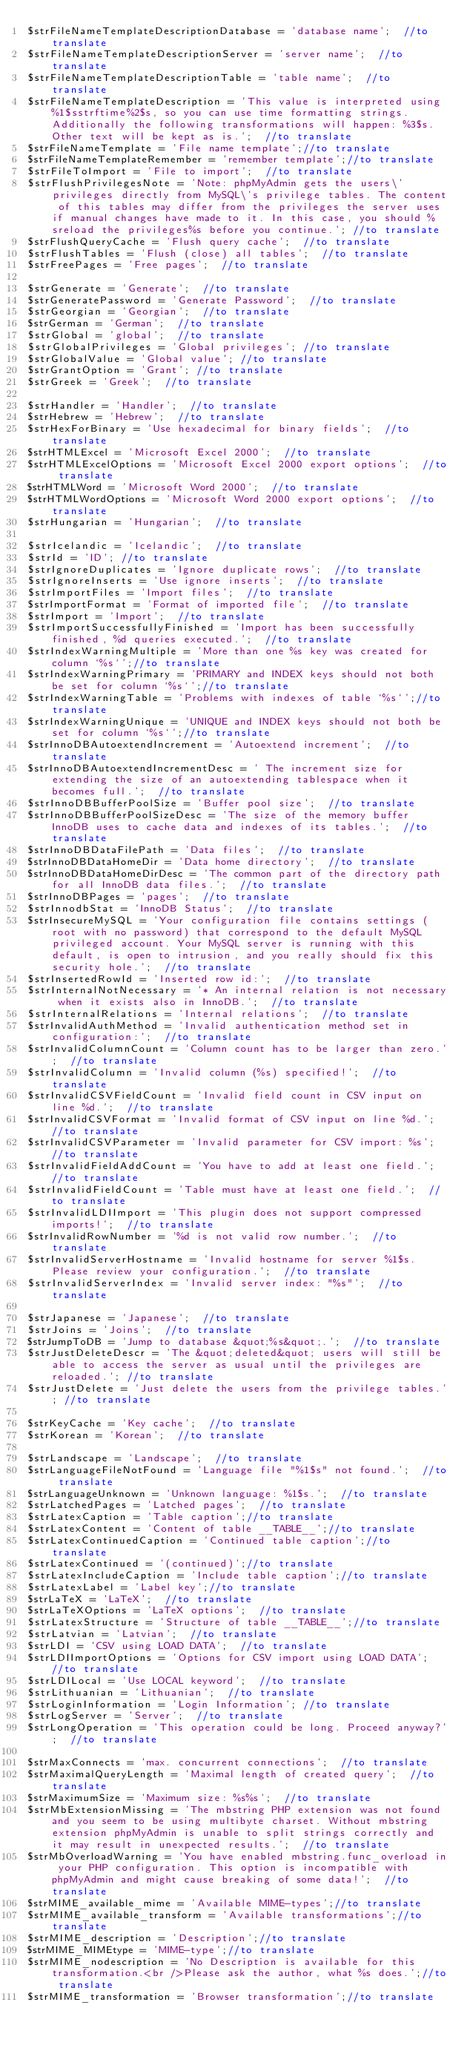Convert code to text. <code><loc_0><loc_0><loc_500><loc_500><_PHP_>$strFileNameTemplateDescriptionDatabase = 'database name';  //to translate
$strFileNameTemplateDescriptionServer = 'server name';  //to translate
$strFileNameTemplateDescriptionTable = 'table name';  //to translate
$strFileNameTemplateDescription = 'This value is interpreted using %1$sstrftime%2$s, so you can use time formatting strings. Additionally the following transformations will happen: %3$s. Other text will be kept as is.';  //to translate
$strFileNameTemplate = 'File name template';//to translate
$strFileNameTemplateRemember = 'remember template';//to translate
$strFileToImport = 'File to import';  //to translate
$strFlushPrivilegesNote = 'Note: phpMyAdmin gets the users\' privileges directly from MySQL\'s privilege tables. The content of this tables may differ from the privileges the server uses if manual changes have made to it. In this case, you should %sreload the privileges%s before you continue.'; //to translate
$strFlushQueryCache = 'Flush query cache';  //to translate
$strFlushTables = 'Flush (close) all tables';  //to translate
$strFreePages = 'Free pages';  //to translate

$strGenerate = 'Generate';  //to translate
$strGeneratePassword = 'Generate Password';  //to translate
$strGeorgian = 'Georgian';  //to translate
$strGerman = 'German';  //to translate
$strGlobal = 'global';  //to translate
$strGlobalPrivileges = 'Global privileges'; //to translate
$strGlobalValue = 'Global value'; //to translate
$strGrantOption = 'Grant'; //to translate
$strGreek = 'Greek';  //to translate

$strHandler = 'Handler';  //to translate
$strHebrew = 'Hebrew';  //to translate
$strHexForBinary = 'Use hexadecimal for binary fields';  //to translate
$strHTMLExcel = 'Microsoft Excel 2000';  //to translate
$strHTMLExcelOptions = 'Microsoft Excel 2000 export options';  //to translate
$strHTMLWord = 'Microsoft Word 2000';  //to translate
$strHTMLWordOptions = 'Microsoft Word 2000 export options';  //to translate
$strHungarian = 'Hungarian';  //to translate

$strIcelandic = 'Icelandic';  //to translate
$strId = 'ID'; //to translate
$strIgnoreDuplicates = 'Ignore duplicate rows';  //to translate
$strIgnoreInserts = 'Use ignore inserts';  //to translate
$strImportFiles = 'Import files';  //to translate
$strImportFormat = 'Format of imported file';  //to translate
$strImport = 'Import';  //to translate
$strImportSuccessfullyFinished = 'Import has been successfully finished, %d queries executed.';  //to translate
$strIndexWarningMultiple = 'More than one %s key was created for column `%s`';//to translate
$strIndexWarningPrimary = 'PRIMARY and INDEX keys should not both be set for column `%s`';//to translate
$strIndexWarningTable = 'Problems with indexes of table `%s`';//to translate
$strIndexWarningUnique = 'UNIQUE and INDEX keys should not both be set for column `%s`';//to translate
$strInnoDBAutoextendIncrement = 'Autoextend increment';  //to translate
$strInnoDBAutoextendIncrementDesc = ' The increment size for extending the size of an autoextending tablespace when it becomes full.';  //to translate
$strInnoDBBufferPoolSize = 'Buffer pool size';  //to translate
$strInnoDBBufferPoolSizeDesc = 'The size of the memory buffer InnoDB uses to cache data and indexes of its tables.';  //to translate
$strInnoDBDataFilePath = 'Data files';  //to translate
$strInnoDBDataHomeDir = 'Data home directory';  //to translate
$strInnoDBDataHomeDirDesc = 'The common part of the directory path for all InnoDB data files.';  //to translate
$strInnoDBPages = 'pages';  //to translate
$strInnodbStat = 'InnoDB Status';  //to translate
$strInsecureMySQL = 'Your configuration file contains settings (root with no password) that correspond to the default MySQL privileged account. Your MySQL server is running with this default, is open to intrusion, and you really should fix this security hole.';  //to translate
$strInsertedRowId = 'Inserted row id:';  //to translate
$strInternalNotNecessary = '* An internal relation is not necessary when it exists also in InnoDB.';  //to translate
$strInternalRelations = 'Internal relations';  //to translate
$strInvalidAuthMethod = 'Invalid authentication method set in configuration:';  //to translate
$strInvalidColumnCount = 'Column count has to be larger than zero.';  //to translate
$strInvalidColumn = 'Invalid column (%s) specified!';  //to translate
$strInvalidCSVFieldCount = 'Invalid field count in CSV input on line %d.';  //to translate
$strInvalidCSVFormat = 'Invalid format of CSV input on line %d.';  //to translate
$strInvalidCSVParameter = 'Invalid parameter for CSV import: %s';  //to translate
$strInvalidFieldAddCount = 'You have to add at least one field.';  //to translate
$strInvalidFieldCount = 'Table must have at least one field.';  //to translate
$strInvalidLDIImport = 'This plugin does not support compressed imports!';  //to translate
$strInvalidRowNumber = '%d is not valid row number.';  //to translate
$strInvalidServerHostname = 'Invalid hostname for server %1$s. Please review your configuration.';  //to translate
$strInvalidServerIndex = 'Invalid server index: "%s"';  //to translate

$strJapanese = 'Japanese';  //to translate
$strJoins = 'Joins';  //to translate
$strJumpToDB = 'Jump to database &quot;%s&quot;.';  //to translate
$strJustDeleteDescr = 'The &quot;deleted&quot; users will still be able to access the server as usual until the privileges are reloaded.'; //to translate
$strJustDelete = 'Just delete the users from the privilege tables.'; //to translate

$strKeyCache = 'Key cache';  //to translate
$strKorean = 'Korean';  //to translate

$strLandscape = 'Landscape';  //to translate
$strLanguageFileNotFound = 'Language file "%1$s" not found.';  //to translate
$strLanguageUnknown = 'Unknown language: %1$s.';  //to translate
$strLatchedPages = 'Latched pages';  //to translate
$strLatexCaption = 'Table caption';//to translate
$strLatexContent = 'Content of table __TABLE__';//to translate
$strLatexContinuedCaption = 'Continued table caption';//to translate
$strLatexContinued = '(continued)';//to translate
$strLatexIncludeCaption = 'Include table caption';//to translate
$strLatexLabel = 'Label key';//to translate
$strLaTeX = 'LaTeX';  //to translate
$strLaTeXOptions = 'LaTeX options';  //to translate
$strLatexStructure = 'Structure of table __TABLE__';//to translate
$strLatvian = 'Latvian';  //to translate
$strLDI = 'CSV using LOAD DATA';  //to translate
$strLDIImportOptions = 'Options for CSV import using LOAD DATA';  //to translate
$strLDILocal = 'Use LOCAL keyword';  //to translate
$strLithuanian = 'Lithuanian';  //to translate
$strLoginInformation = 'Login Information'; //to translate
$strLogServer = 'Server';  //to translate
$strLongOperation = 'This operation could be long. Proceed anyway?';  //to translate

$strMaxConnects = 'max. concurrent connections';  //to translate
$strMaximalQueryLength = 'Maximal length of created query';  //to translate
$strMaximumSize = 'Maximum size: %s%s';  //to translate
$strMbExtensionMissing = 'The mbstring PHP extension was not found and you seem to be using multibyte charset. Without mbstring extension phpMyAdmin is unable to split strings correctly and it may result in unexpected results.';  //to translate
$strMbOverloadWarning = 'You have enabled mbstring.func_overload in your PHP configuration. This option is incompatible with phpMyAdmin and might cause breaking of some data!';  //to translate
$strMIME_available_mime = 'Available MIME-types';//to translate
$strMIME_available_transform = 'Available transformations';//to translate
$strMIME_description = 'Description';//to translate
$strMIME_MIMEtype = 'MIME-type';//to translate
$strMIME_nodescription = 'No Description is available for this transformation.<br />Please ask the author, what %s does.';//to translate
$strMIME_transformation = 'Browser transformation';//to translate</code> 